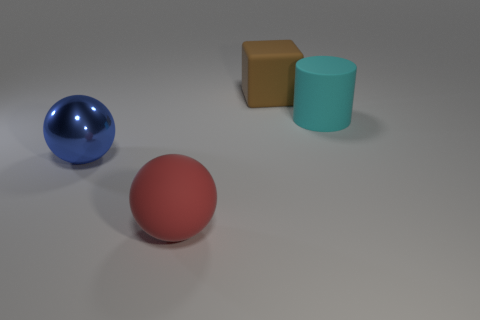Add 2 red metallic cylinders. How many objects exist? 6 Subtract all cubes. How many objects are left? 3 Subtract all large red balls. Subtract all tiny yellow shiny cylinders. How many objects are left? 3 Add 4 large red things. How many large red things are left? 5 Add 4 large brown rubber spheres. How many large brown rubber spheres exist? 4 Subtract 0 green balls. How many objects are left? 4 